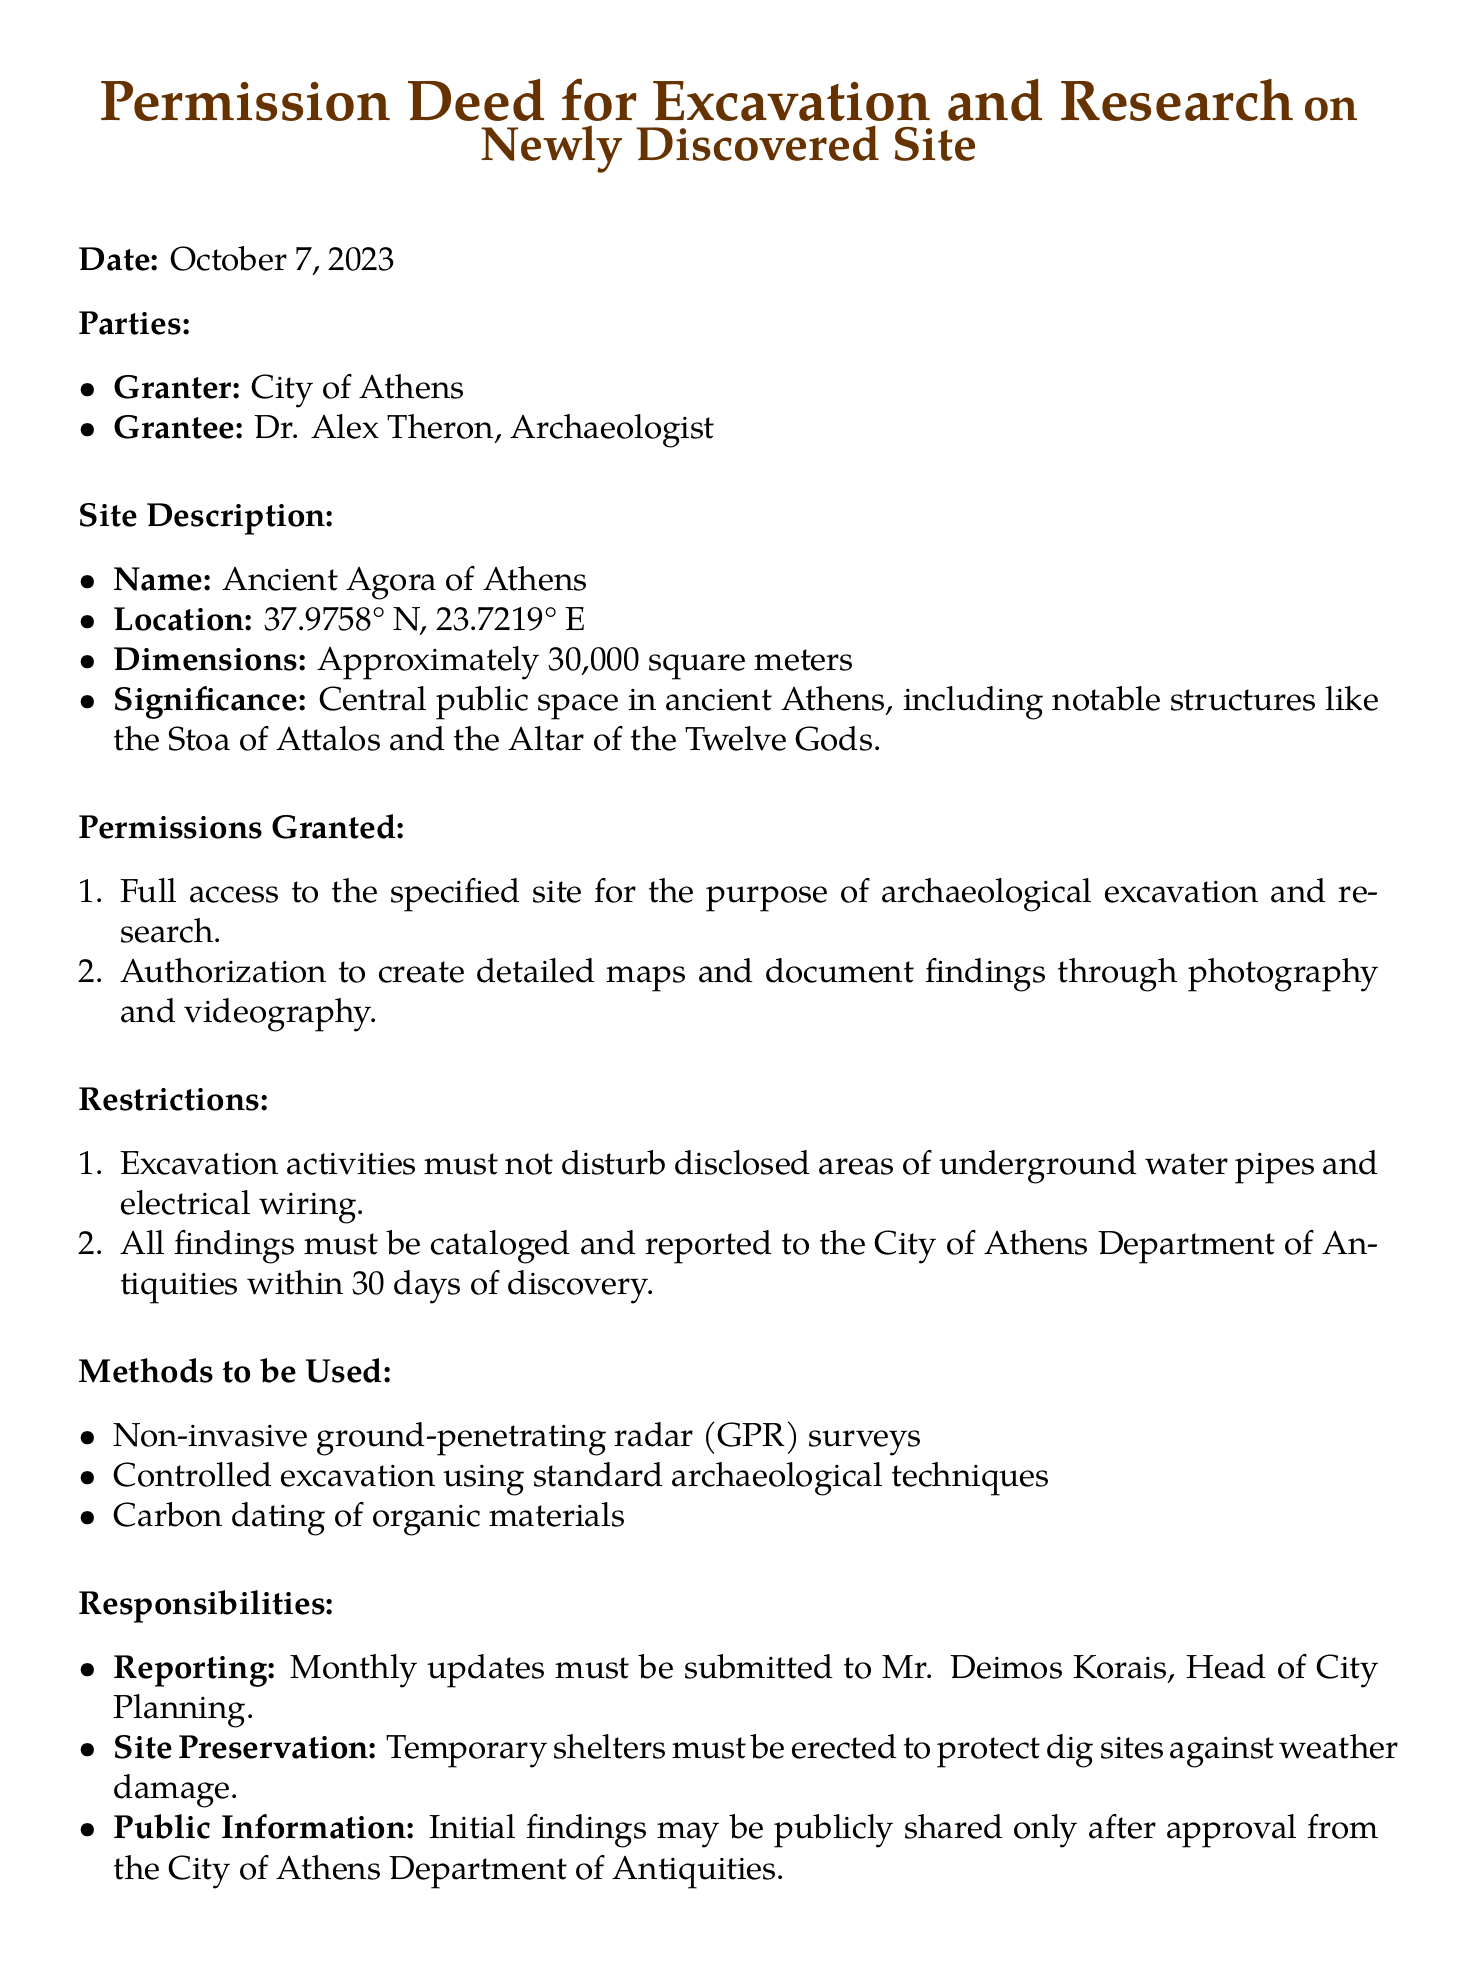What is the date of the document? The date is specifically mentioned in the document as the date of signing.
Answer: October 7, 2023 Who is the granter of the permission deed? The granter is identified at the beginning of the document under the parties section.
Answer: City of Athens What is the name of the grantee? The grantee is listed in the document under the parties section, referring to the individual who receives permission.
Answer: Dr. Alex Theron What is the location of the site? The detailed location is provided within the site description section of the document.
Answer: 37.9758° N, 23.7219° E What is one of the methods to be used during the excavation? The methods are listed under the methods to be used section, highlighting the techniques for excavation.
Answer: Non-invasive ground-penetrating radar (GPR) surveys How long does the grantee have to report findings to the City of Athens? The time frame for reporting findings is mentioned in the restrictions section.
Answer: 30 days Who must receive monthly updates about the excavation? The responsibilities section mentions the individual to whom updates must be reported.
Answer: Mr. Deimos Korais What is the total funding amount provided by the City of Athens? The funding details are specified under the funding and resources section.
Answer: €50,000 What type of techniques are permitted for excavation according to the document? The excavation techniques mentioned in the methods to be used section clarify what methods are acceptable.
Answer: Controlled excavation using standard archaeological techniques 